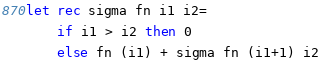Convert code to text. <code><loc_0><loc_0><loc_500><loc_500><_OCaml_>let rec sigma fn i1 i2=
	if i1 > i2 then 0
	else fn (i1) + sigma fn (i1+1) i2
</code> 